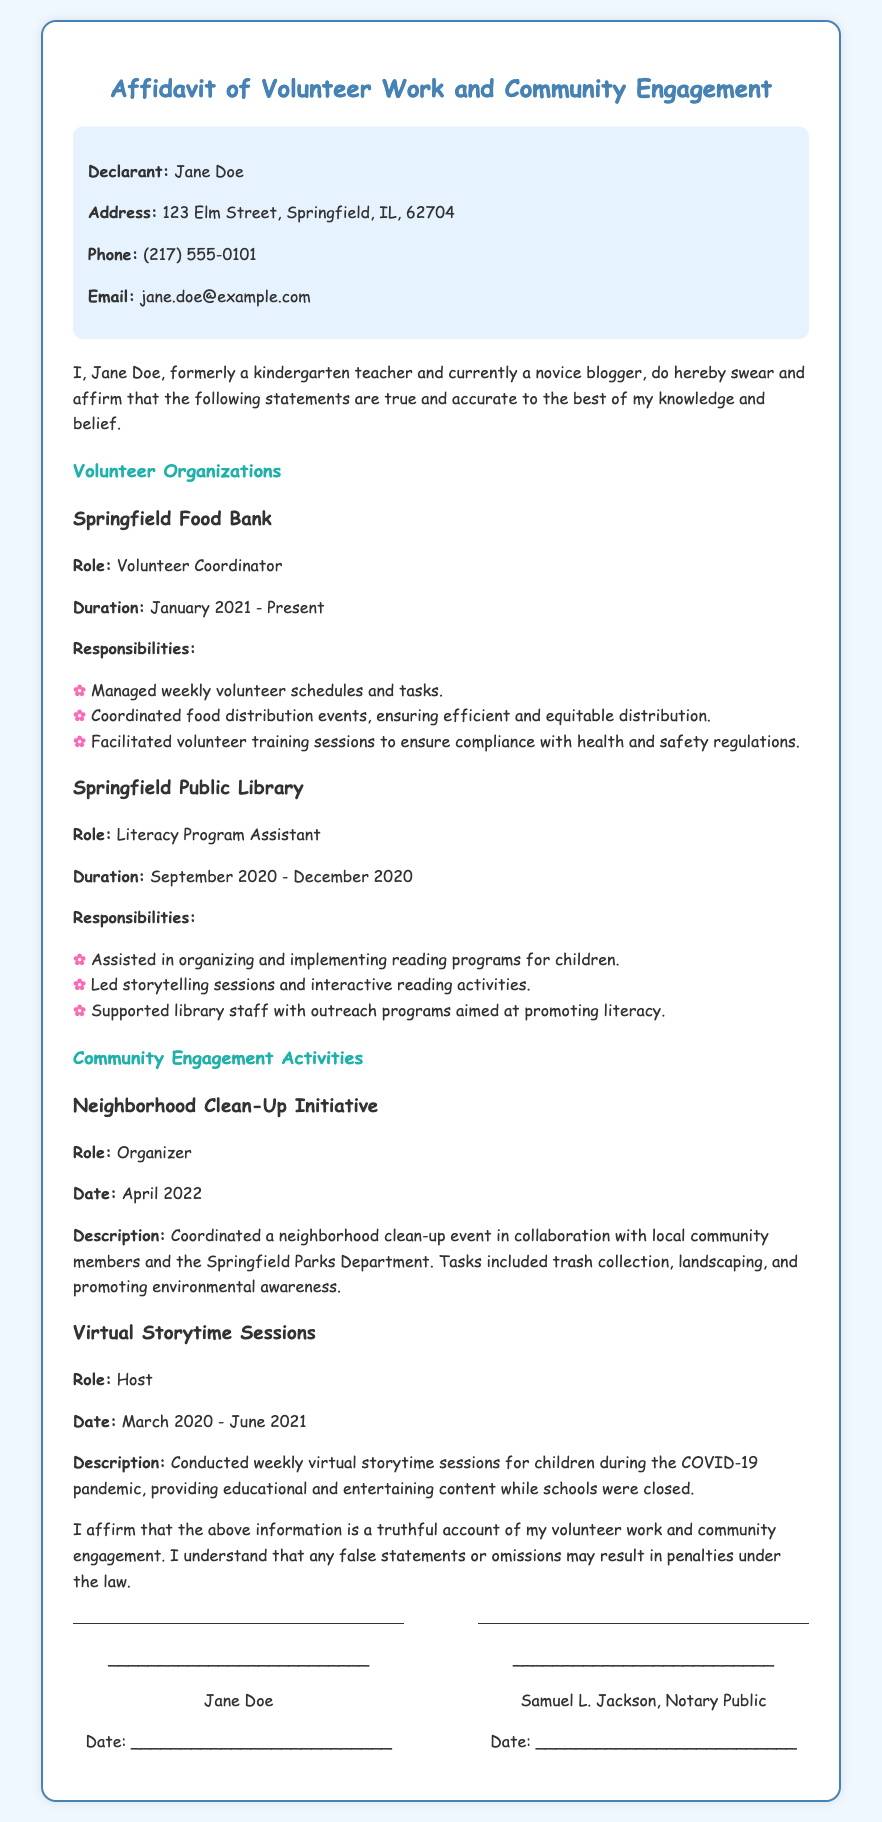What is the name of the declarant? The name of the declarant is the person making the affidavit, which is provided at the beginning of the document.
Answer: Jane Doe What organization does Jane Doe work with as a Volunteer Coordinator? The organization where Jane Doe holds the position of Volunteer Coordinator is mentioned under the volunteer section.
Answer: Springfield Food Bank When did Jane Doe serve as a Literacy Program Assistant? The duration of Jane Doe's role as a Literacy Program Assistant is specified as a specific time period in the document.
Answer: September 2020 - December 2020 How many responsibilities are listed for the Springfield Food Bank? The number of responsibilities listed indicates the variety of tasks performed at the organization, given in bullet points.
Answer: Three What role did Jane Doe have during the Neighborhood Clean-Up Initiative? The document outlines Jane Doe's role in that specific community engagement initiative, stated clearly under the event description.
Answer: Organizer What was the main purpose of the Virtual Storytime Sessions? The purpose of the Virtual Storytime Sessions is detailed in the description to reflect the educational nature of the activity.
Answer: Educational and entertaining content Who is mentioned as the Notary Public in the signature section? The identification of the Notary Public is clearly highlighted in the signature area of the document.
Answer: Samuel L. Jackson What year did Jane Doe start volunteering at the Springfield Food Bank? The start date provided in the document indicates the beginning of her volunteer work at this organization.
Answer: January 2021 